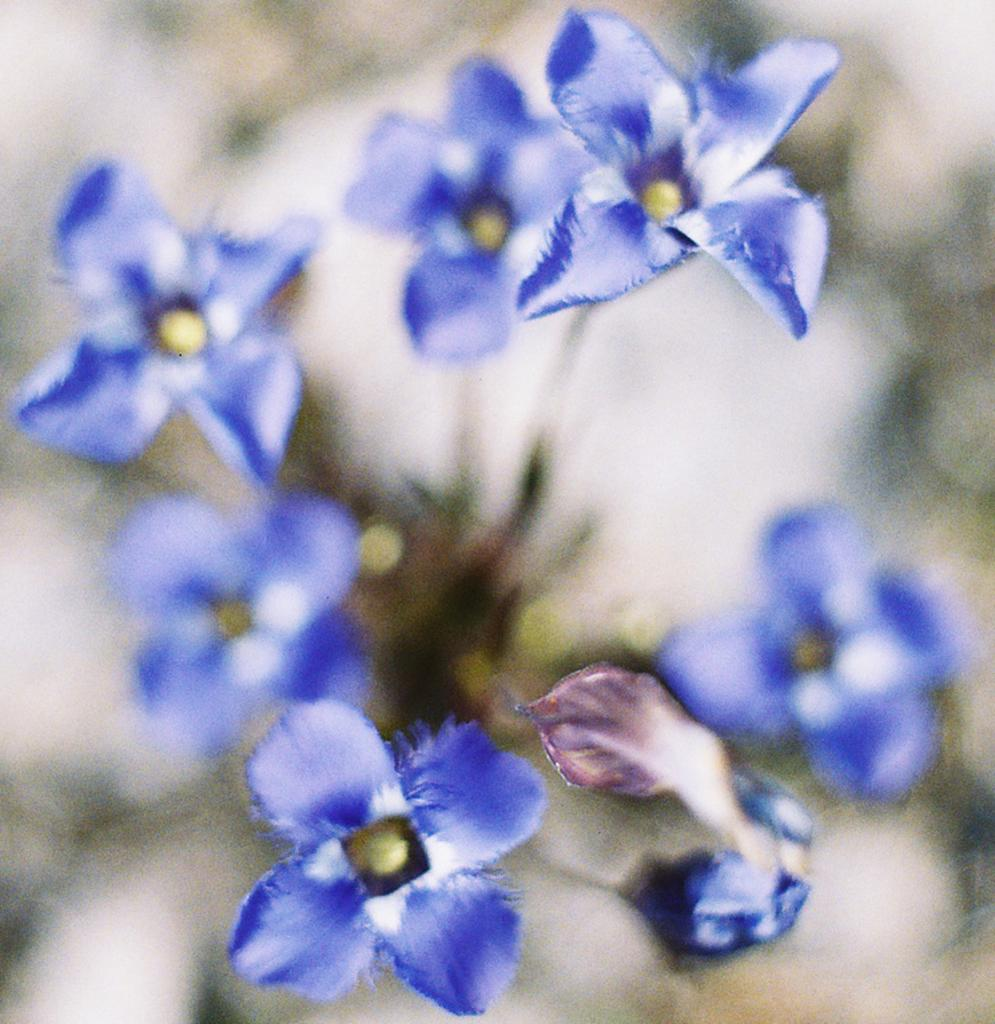What color are the flowers in the image? The flowers in the image are blue colored. What additional color can be seen in the middle of the blue flowers? The blue flowers have yellow in the middle. What type of game is being played in the image? There is no game present in the image; it features blue colored flowers with yellow in the middle. How does the stomach of the blue flowers appear in the image? There is no reference to a stomach in the image, as it features flowers and not living organisms. 